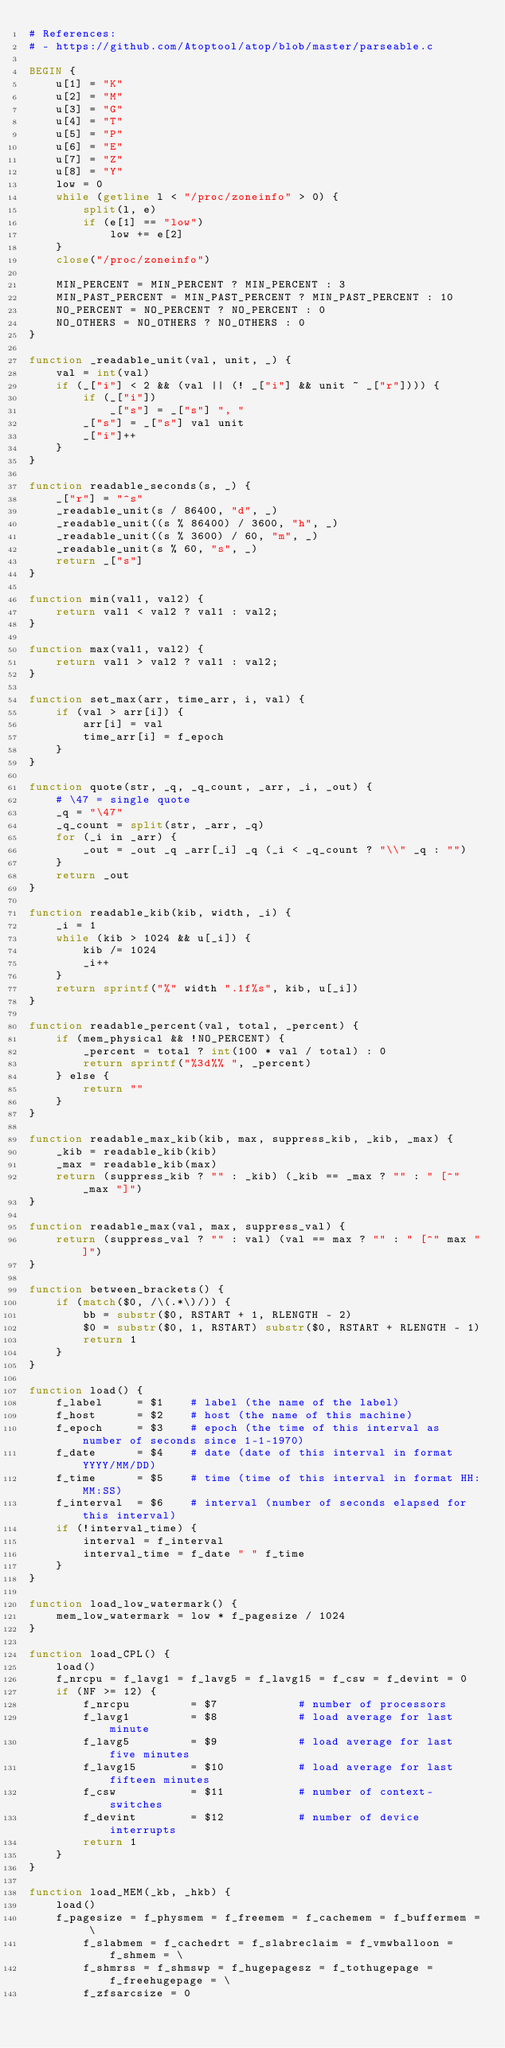Convert code to text. <code><loc_0><loc_0><loc_500><loc_500><_Awk_># References:
# - https://github.com/Atoptool/atop/blob/master/parseable.c

BEGIN {
    u[1] = "K"
    u[2] = "M"
    u[3] = "G"
    u[4] = "T"
    u[5] = "P"
    u[6] = "E"
    u[7] = "Z"
    u[8] = "Y"
    low = 0
    while (getline l < "/proc/zoneinfo" > 0) {
        split(l, e)
        if (e[1] == "low")
            low += e[2]
    }
    close("/proc/zoneinfo")

    MIN_PERCENT = MIN_PERCENT ? MIN_PERCENT : 3
    MIN_PAST_PERCENT = MIN_PAST_PERCENT ? MIN_PAST_PERCENT : 10
    NO_PERCENT = NO_PERCENT ? NO_PERCENT : 0
    NO_OTHERS = NO_OTHERS ? NO_OTHERS : 0
}

function _readable_unit(val, unit, _) {
    val = int(val)
    if (_["i"] < 2 && (val || (! _["i"] && unit ~ _["r"]))) {
        if (_["i"])
            _["s"] = _["s"] ", "
        _["s"] = _["s"] val unit
        _["i"]++
    }
}

function readable_seconds(s, _) {
    _["r"] = "^s"
    _readable_unit(s / 86400, "d", _)
    _readable_unit((s % 86400) / 3600, "h", _)
    _readable_unit((s % 3600) / 60, "m", _)
    _readable_unit(s % 60, "s", _)
    return _["s"]
}

function min(val1, val2) {
    return val1 < val2 ? val1 : val2;
}

function max(val1, val2) {
    return val1 > val2 ? val1 : val2;
}

function set_max(arr, time_arr, i, val) {
    if (val > arr[i]) {
        arr[i] = val
        time_arr[i] = f_epoch
    }
}

function quote(str, _q, _q_count, _arr, _i, _out) {
    # \47 = single quote
    _q = "\47"
    _q_count = split(str, _arr, _q)
    for (_i in _arr) {
        _out = _out _q _arr[_i] _q (_i < _q_count ? "\\" _q : "")
    }
    return _out
}

function readable_kib(kib, width, _i) {
    _i = 1
    while (kib > 1024 && u[_i]) {
        kib /= 1024
        _i++
    }
    return sprintf("%" width ".1f%s", kib, u[_i])
}

function readable_percent(val, total, _percent) {
    if (mem_physical && !NO_PERCENT) {
        _percent = total ? int(100 * val / total) : 0
        return sprintf("%3d%% ", _percent)
    } else {
        return ""
    }
}

function readable_max_kib(kib, max, suppress_kib, _kib, _max) {
    _kib = readable_kib(kib)
    _max = readable_kib(max)
    return (suppress_kib ? "" : _kib) (_kib == _max ? "" : " [^" _max "]")
}

function readable_max(val, max, suppress_val) {
    return (suppress_val ? "" : val) (val == max ? "" : " [^" max "]")
}

function between_brackets() {
    if (match($0, /\(.*\)/)) {
        bb = substr($0, RSTART + 1, RLENGTH - 2)
        $0 = substr($0, 1, RSTART) substr($0, RSTART + RLENGTH - 1)
        return 1
    }
}

function load() {
    f_label     = $1    # label (the name of the label)
    f_host      = $2    # host (the name of this machine)
    f_epoch     = $3    # epoch (the time of this interval as number of seconds since 1-1-1970)
    f_date      = $4    # date (date of this interval in format YYYY/MM/DD)
    f_time      = $5    # time (time of this interval in format HH:MM:SS)
    f_interval  = $6    # interval (number of seconds elapsed for this interval)
    if (!interval_time) {
        interval = f_interval
        interval_time = f_date " " f_time
    }
}

function load_low_watermark() {
    mem_low_watermark = low * f_pagesize / 1024
}

function load_CPL() {
    load()
    f_nrcpu = f_lavg1 = f_lavg5 = f_lavg15 = f_csw = f_devint = 0
    if (NF >= 12) {
        f_nrcpu         = $7            # number of processors
        f_lavg1         = $8            # load average for last minute
        f_lavg5         = $9            # load average for last five minutes
        f_lavg15        = $10           # load average for last fifteen minutes
        f_csw           = $11           # number of context-switches
        f_devint        = $12           # number of device interrupts
        return 1
    }
}

function load_MEM(_kb, _hkb) {
    load()
    f_pagesize = f_physmem = f_freemem = f_cachemem = f_buffermem = \
        f_slabmem = f_cachedrt = f_slabreclaim = f_vmwballoon = f_shmem = \
        f_shmrss = f_shmswp = f_hugepagesz = f_tothugepage = f_freehugepage = \
        f_zfsarcsize = 0</code> 